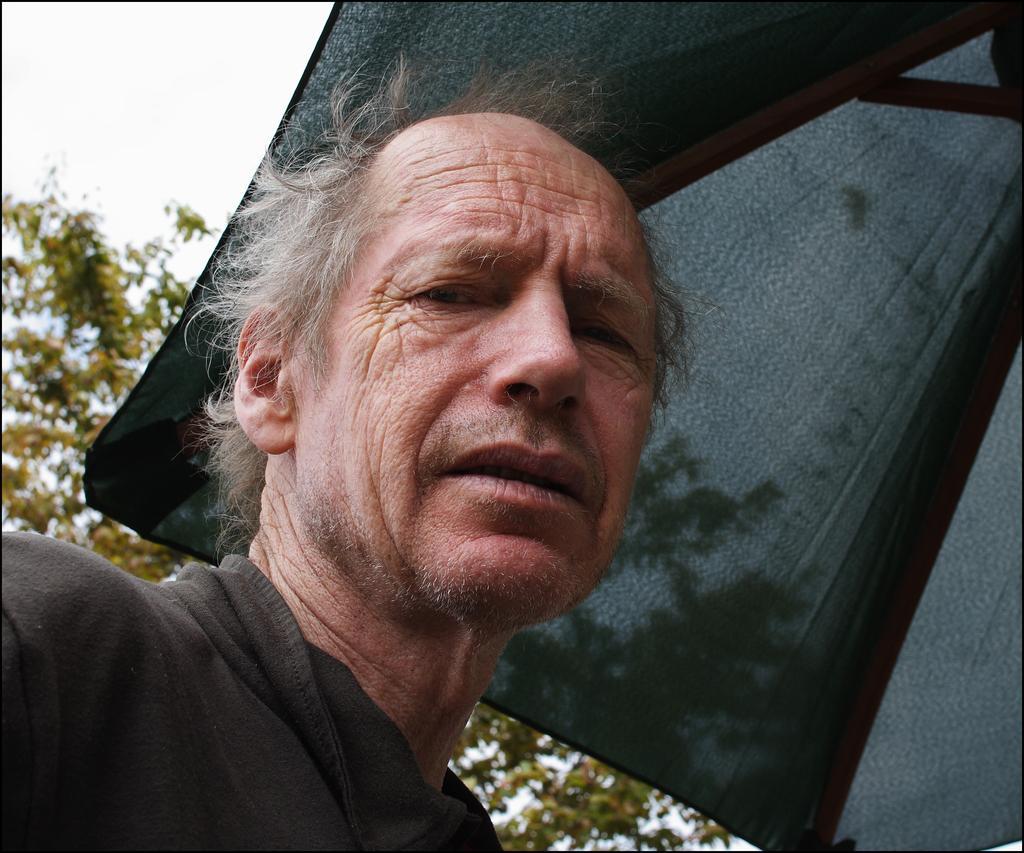Please provide a concise description of this image. In front of the image there is a person. On top of the person's head there is a tent. In the background of the image there are trees. 